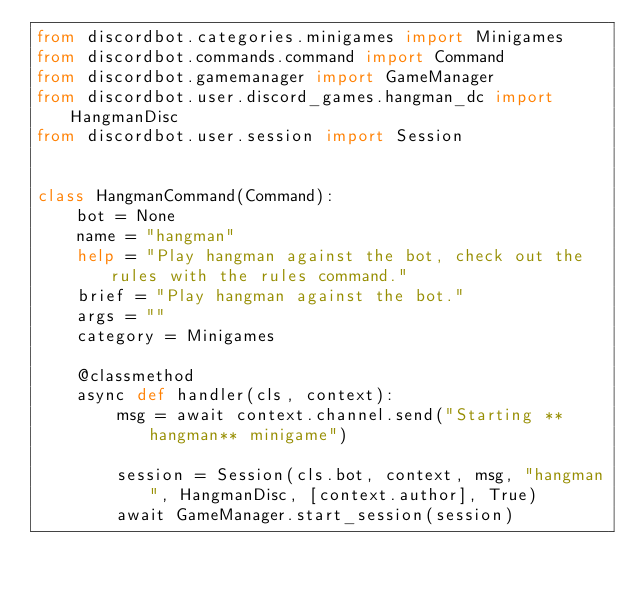Convert code to text. <code><loc_0><loc_0><loc_500><loc_500><_Python_>from discordbot.categories.minigames import Minigames
from discordbot.commands.command import Command
from discordbot.gamemanager import GameManager
from discordbot.user.discord_games.hangman_dc import HangmanDisc
from discordbot.user.session import Session


class HangmanCommand(Command):
    bot = None
    name = "hangman"
    help = "Play hangman against the bot, check out the rules with the rules command."
    brief = "Play hangman against the bot."
    args = ""
    category = Minigames

    @classmethod
    async def handler(cls, context):
        msg = await context.channel.send("Starting **hangman** minigame")

        session = Session(cls.bot, context, msg, "hangman", HangmanDisc, [context.author], True)
        await GameManager.start_session(session)
</code> 